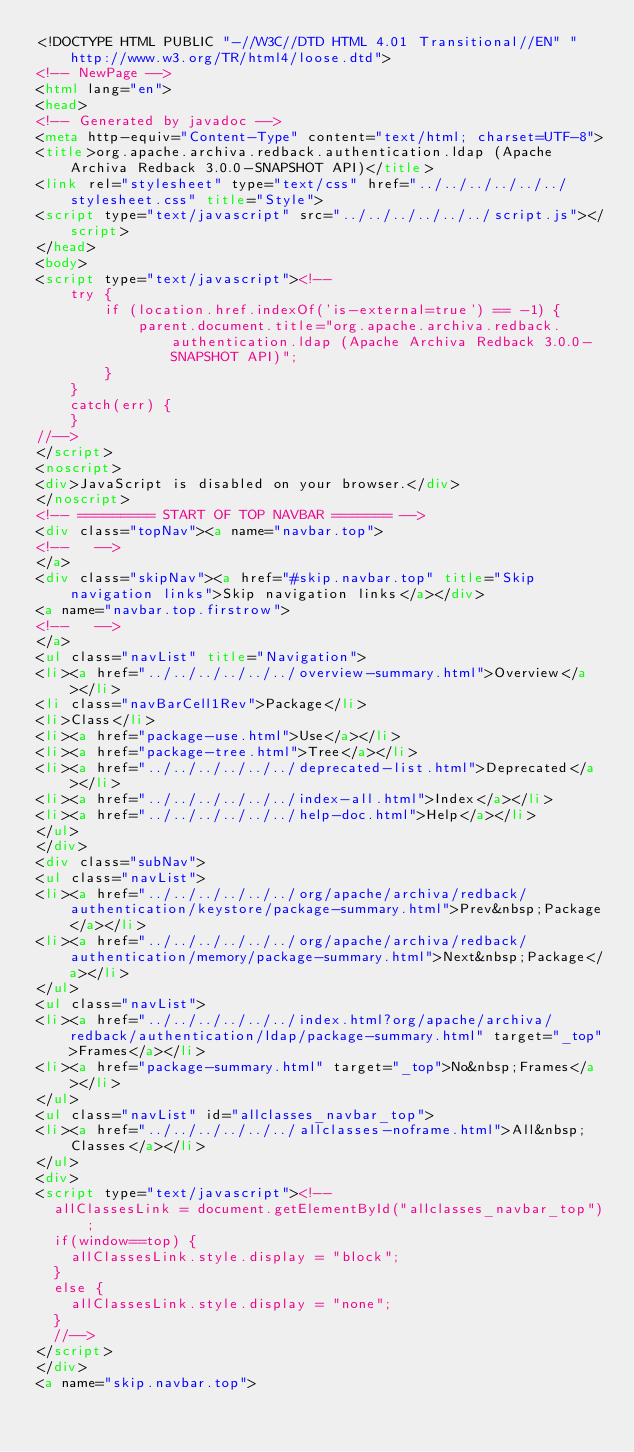<code> <loc_0><loc_0><loc_500><loc_500><_HTML_><!DOCTYPE HTML PUBLIC "-//W3C//DTD HTML 4.01 Transitional//EN" "http://www.w3.org/TR/html4/loose.dtd">
<!-- NewPage -->
<html lang="en">
<head>
<!-- Generated by javadoc -->
<meta http-equiv="Content-Type" content="text/html; charset=UTF-8">
<title>org.apache.archiva.redback.authentication.ldap (Apache Archiva Redback 3.0.0-SNAPSHOT API)</title>
<link rel="stylesheet" type="text/css" href="../../../../../../stylesheet.css" title="Style">
<script type="text/javascript" src="../../../../../../script.js"></script>
</head>
<body>
<script type="text/javascript"><!--
    try {
        if (location.href.indexOf('is-external=true') == -1) {
            parent.document.title="org.apache.archiva.redback.authentication.ldap (Apache Archiva Redback 3.0.0-SNAPSHOT API)";
        }
    }
    catch(err) {
    }
//-->
</script>
<noscript>
<div>JavaScript is disabled on your browser.</div>
</noscript>
<!-- ========= START OF TOP NAVBAR ======= -->
<div class="topNav"><a name="navbar.top">
<!--   -->
</a>
<div class="skipNav"><a href="#skip.navbar.top" title="Skip navigation links">Skip navigation links</a></div>
<a name="navbar.top.firstrow">
<!--   -->
</a>
<ul class="navList" title="Navigation">
<li><a href="../../../../../../overview-summary.html">Overview</a></li>
<li class="navBarCell1Rev">Package</li>
<li>Class</li>
<li><a href="package-use.html">Use</a></li>
<li><a href="package-tree.html">Tree</a></li>
<li><a href="../../../../../../deprecated-list.html">Deprecated</a></li>
<li><a href="../../../../../../index-all.html">Index</a></li>
<li><a href="../../../../../../help-doc.html">Help</a></li>
</ul>
</div>
<div class="subNav">
<ul class="navList">
<li><a href="../../../../../../org/apache/archiva/redback/authentication/keystore/package-summary.html">Prev&nbsp;Package</a></li>
<li><a href="../../../../../../org/apache/archiva/redback/authentication/memory/package-summary.html">Next&nbsp;Package</a></li>
</ul>
<ul class="navList">
<li><a href="../../../../../../index.html?org/apache/archiva/redback/authentication/ldap/package-summary.html" target="_top">Frames</a></li>
<li><a href="package-summary.html" target="_top">No&nbsp;Frames</a></li>
</ul>
<ul class="navList" id="allclasses_navbar_top">
<li><a href="../../../../../../allclasses-noframe.html">All&nbsp;Classes</a></li>
</ul>
<div>
<script type="text/javascript"><!--
  allClassesLink = document.getElementById("allclasses_navbar_top");
  if(window==top) {
    allClassesLink.style.display = "block";
  }
  else {
    allClassesLink.style.display = "none";
  }
  //-->
</script>
</div>
<a name="skip.navbar.top"></code> 